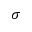<formula> <loc_0><loc_0><loc_500><loc_500>\sigma</formula> 